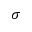<formula> <loc_0><loc_0><loc_500><loc_500>\sigma</formula> 